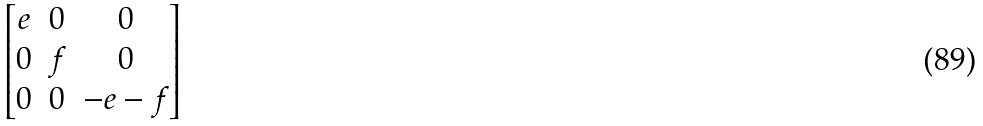Convert formula to latex. <formula><loc_0><loc_0><loc_500><loc_500>\begin{bmatrix} e & 0 & 0 \\ 0 & f & 0 \\ 0 & 0 & - e - f \end{bmatrix}</formula> 